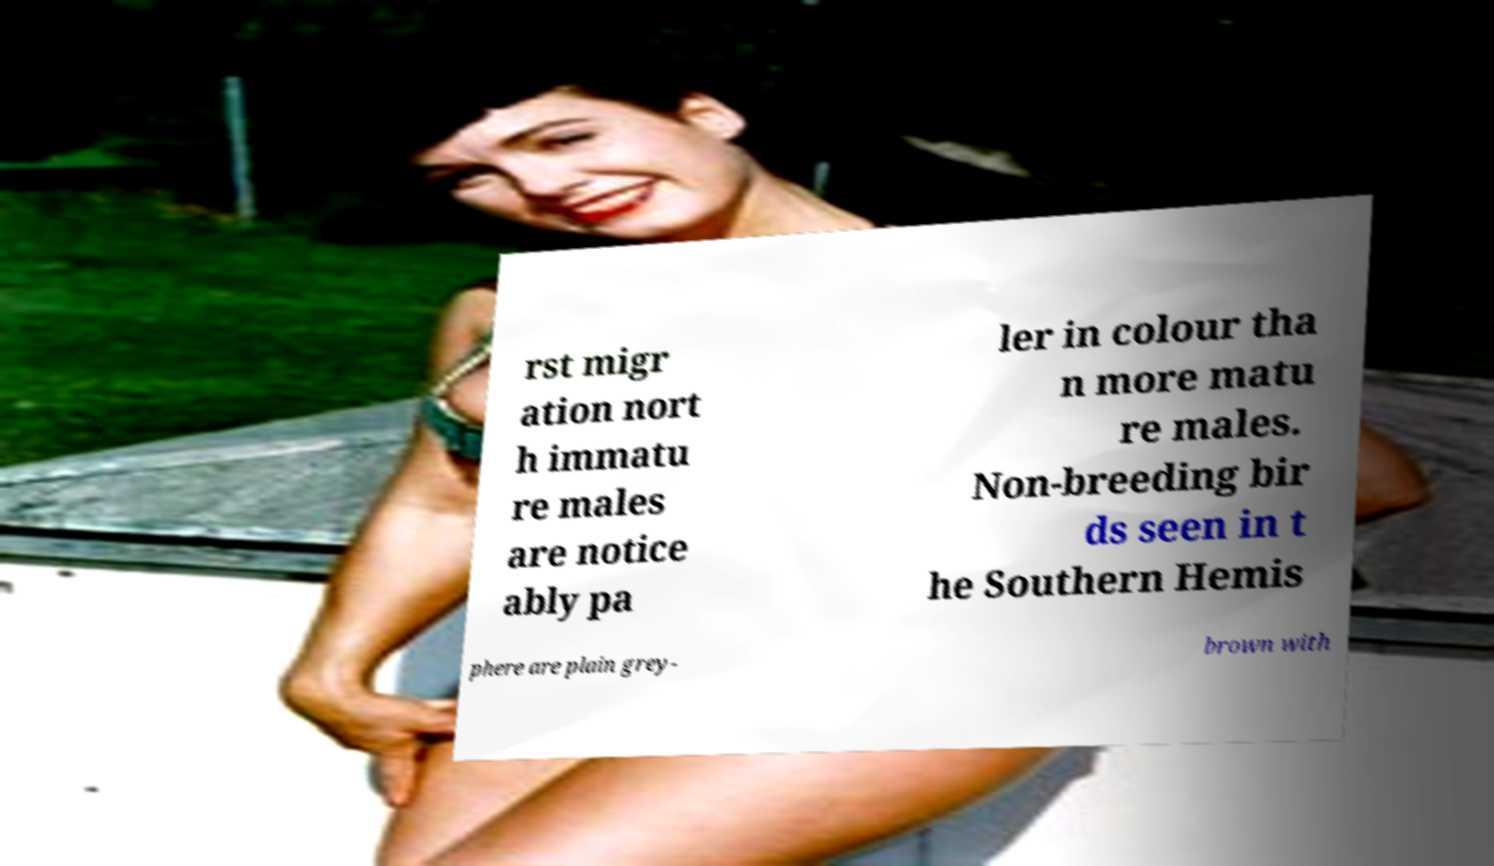Could you assist in decoding the text presented in this image and type it out clearly? rst migr ation nort h immatu re males are notice ably pa ler in colour tha n more matu re males. Non-breeding bir ds seen in t he Southern Hemis phere are plain grey- brown with 